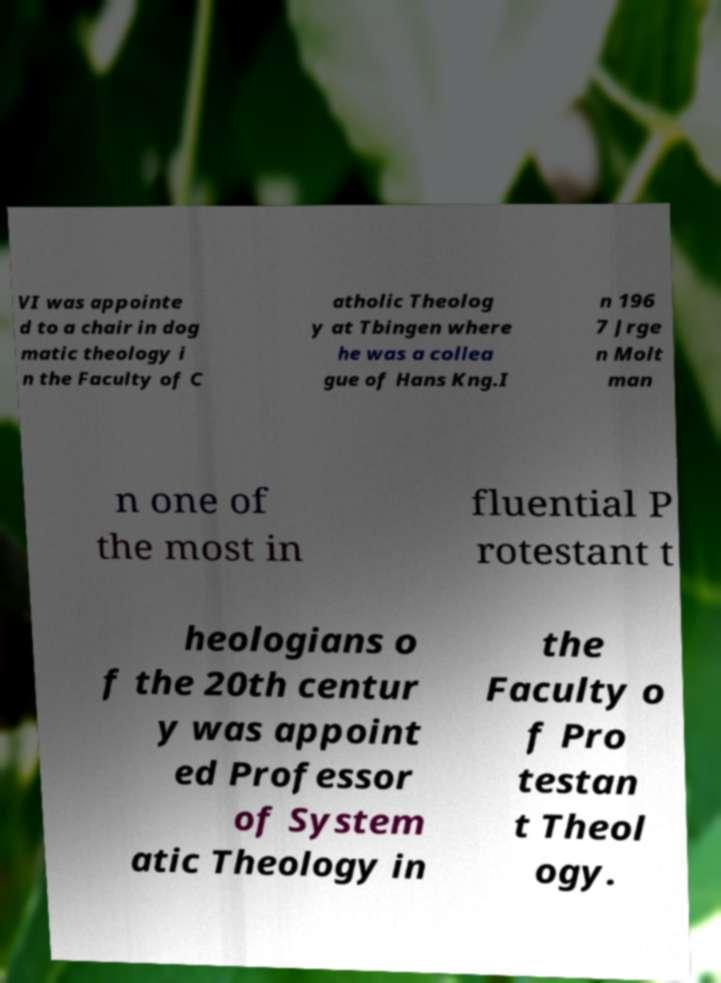What messages or text are displayed in this image? I need them in a readable, typed format. VI was appointe d to a chair in dog matic theology i n the Faculty of C atholic Theolog y at Tbingen where he was a collea gue of Hans Kng.I n 196 7 Jrge n Molt man n one of the most in fluential P rotestant t heologians o f the 20th centur y was appoint ed Professor of System atic Theology in the Faculty o f Pro testan t Theol ogy. 